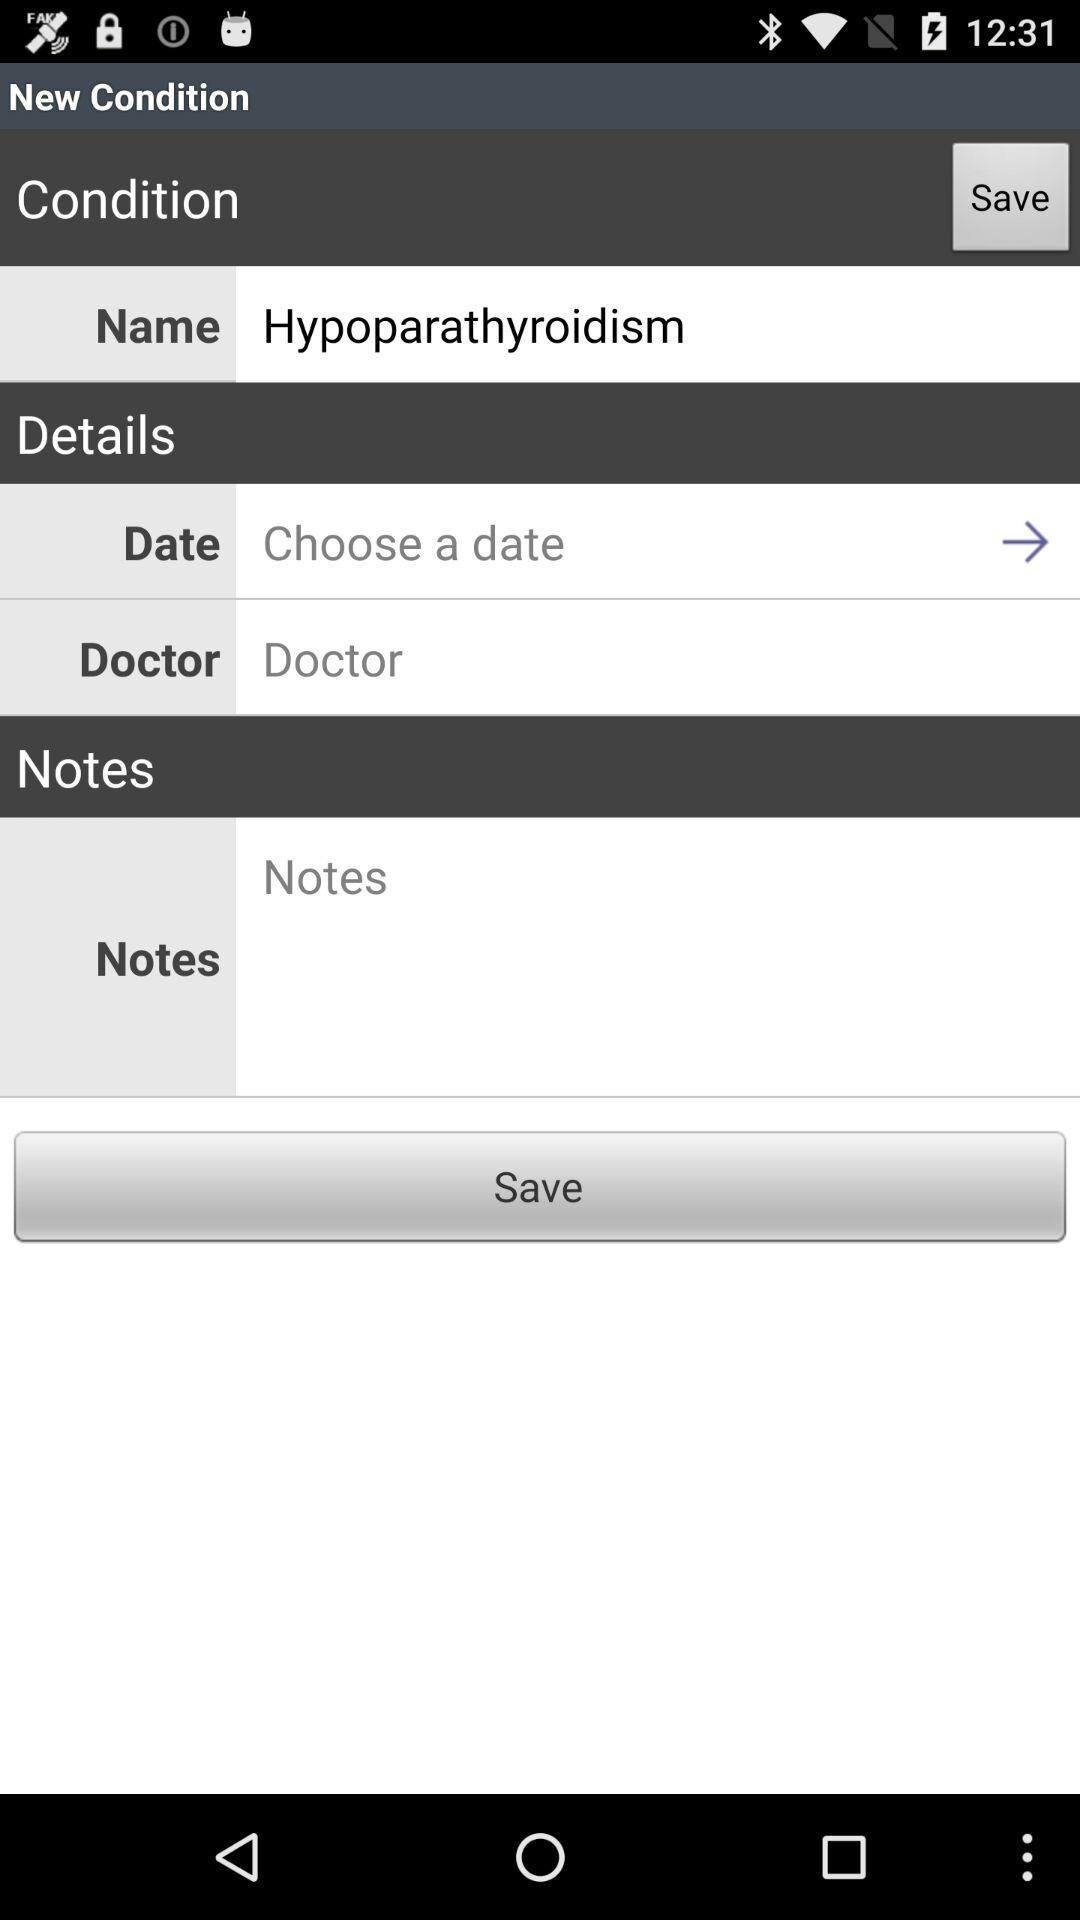What date is chosen?
When the provided information is insufficient, respond with <no answer>. <no answer> 